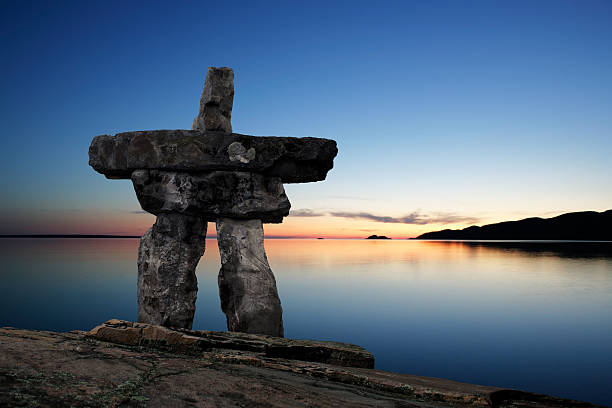Can you tell me more about the cultural significance of the Inukshuk? The Inukshuk holds a profound cultural significance for the Inuit people. Originally used as navigational aids and communication tools in the harsh environments of the Arctic, these stone structures were designed to resemble humans, instilling a sense of camaraderie and connection among the community. They often marked hunting grounds or pointed to fishing spots or safe passages through the treacherous Arctic terrain. Beyond their practical utility, Inukshuks also serve spiritual purposes, symbolizing guidance, protection, and solidarity within the Inuit culture. Their construction requires patience and mastery, reflecting the harmony between the Inuit way of life and nature. How does this image evoke a sense of peace and tranquility? Be descriptive. This image invokes a sense of peace and tranquility through several key elements. The soothing color palette, with a deep blue sky gently transitioning into soft oranges and pinks near the horizon, creates a calming visual effect. The water, perfectly still and reflecting the sky's gentle hues, adds to the serene atmosphere. The presence of the Inukshuk, sturdily rooted on the rocky shore, offers a sense of stability and timelessness. The expansive horizon, with distant landforms silhouetted against the setting sun, invites contemplation and a feeling of boundless openness. Collectively, these elements work harmoniously to evoke a deep sense of quiet and reflective calm. 